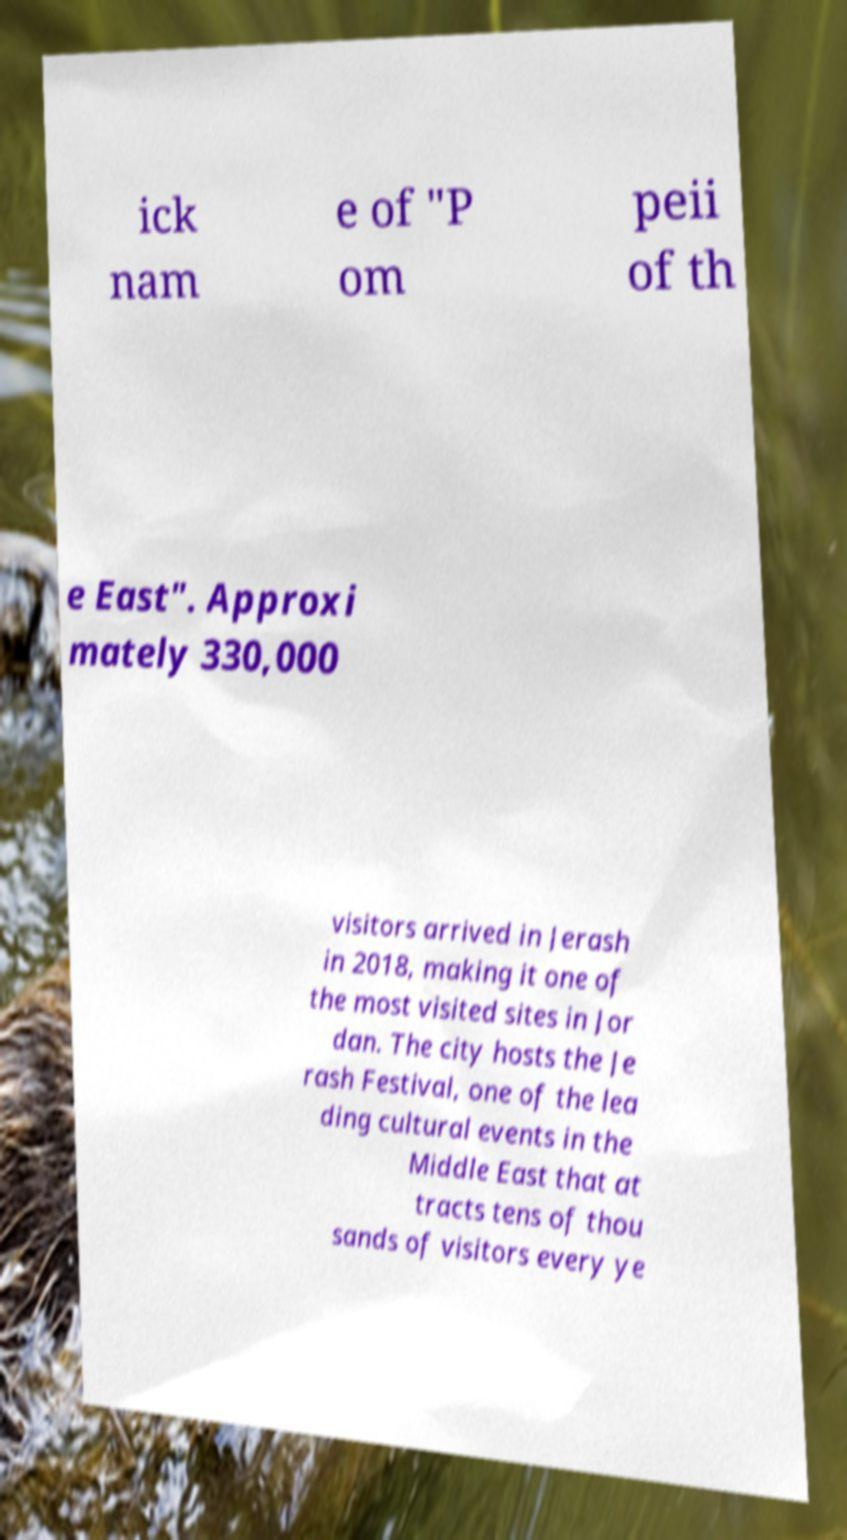For documentation purposes, I need the text within this image transcribed. Could you provide that? ick nam e of "P om peii of th e East". Approxi mately 330,000 visitors arrived in Jerash in 2018, making it one of the most visited sites in Jor dan. The city hosts the Je rash Festival, one of the lea ding cultural events in the Middle East that at tracts tens of thou sands of visitors every ye 